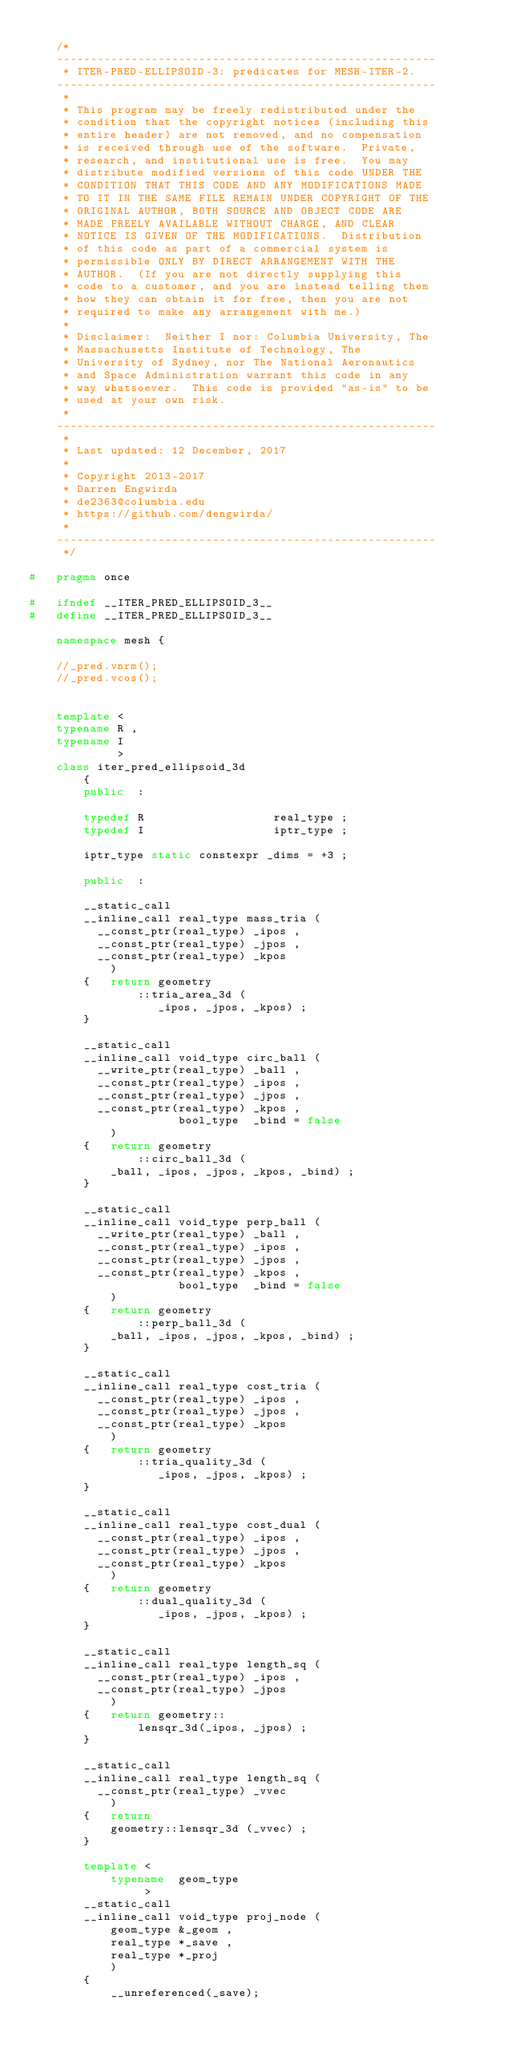Convert code to text. <code><loc_0><loc_0><loc_500><loc_500><_C++_>
    /*
    --------------------------------------------------------
     * ITER-PRED-ELLIPSOID-3: predicates for MESH-ITER-2.
    --------------------------------------------------------
     *
     * This program may be freely redistributed under the 
     * condition that the copyright notices (including this 
     * entire header) are not removed, and no compensation 
     * is received through use of the software.  Private, 
     * research, and institutional use is free.  You may 
     * distribute modified versions of this code UNDER THE 
     * CONDITION THAT THIS CODE AND ANY MODIFICATIONS MADE 
     * TO IT IN THE SAME FILE REMAIN UNDER COPYRIGHT OF THE 
     * ORIGINAL AUTHOR, BOTH SOURCE AND OBJECT CODE ARE 
     * MADE FREELY AVAILABLE WITHOUT CHARGE, AND CLEAR 
     * NOTICE IS GIVEN OF THE MODIFICATIONS.  Distribution 
     * of this code as part of a commercial system is 
     * permissible ONLY BY DIRECT ARRANGEMENT WITH THE 
     * AUTHOR.  (If you are not directly supplying this 
     * code to a customer, and you are instead telling them 
     * how they can obtain it for free, then you are not 
     * required to make any arrangement with me.) 
     *
     * Disclaimer:  Neither I nor: Columbia University, The
     * Massachusetts Institute of Technology, The 
     * University of Sydney, nor The National Aeronautics
     * and Space Administration warrant this code in any 
     * way whatsoever.  This code is provided "as-is" to be 
     * used at your own risk.
     *
    --------------------------------------------------------
     *
     * Last updated: 12 December, 2017
     *
     * Copyright 2013-2017
     * Darren Engwirda
     * de2363@columbia.edu
     * https://github.com/dengwirda/
     *
    --------------------------------------------------------
     */

#   pragma once

#   ifndef __ITER_PRED_ELLIPSOID_3__
#   define __ITER_PRED_ELLIPSOID_3__

    namespace mesh {

    //_pred.vnrm();
    //_pred.vcos();
    
    
    template <
    typename R ,
    typename I
             >
    class iter_pred_ellipsoid_3d
        {
        public  :
        
        typedef R                   real_type ;
        typedef I                   iptr_type ;
        
        iptr_type static constexpr _dims = +3 ; 
         
        public  :
        
        __static_call
        __inline_call real_type mass_tria (
          __const_ptr(real_type) _ipos ,
          __const_ptr(real_type) _jpos ,
          __const_ptr(real_type) _kpos
            )
        {   return geometry
                ::tria_area_3d (
                   _ipos, _jpos, _kpos) ;
        }
        
        __static_call
        __inline_call void_type circ_ball (
          __write_ptr(real_type) _ball ,
          __const_ptr(real_type) _ipos ,
          __const_ptr(real_type) _jpos ,
          __const_ptr(real_type) _kpos ,
                      bool_type  _bind = false
            )
        {   return geometry
                ::circ_ball_3d (
            _ball, _ipos, _jpos, _kpos, _bind) ;
        }
        
        __static_call
        __inline_call void_type perp_ball (
          __write_ptr(real_type) _ball ,
          __const_ptr(real_type) _ipos ,
          __const_ptr(real_type) _jpos ,
          __const_ptr(real_type) _kpos ,
                      bool_type  _bind = false
            )
        {   return geometry
                ::perp_ball_3d (
            _ball, _ipos, _jpos, _kpos, _bind) ;
        }
        
        __static_call
        __inline_call real_type cost_tria (
          __const_ptr(real_type) _ipos ,
          __const_ptr(real_type) _jpos ,
          __const_ptr(real_type) _kpos
            )
        {   return geometry
                ::tria_quality_3d (
                   _ipos, _jpos, _kpos) ;
        }
        
        __static_call
        __inline_call real_type cost_dual (
          __const_ptr(real_type) _ipos ,
          __const_ptr(real_type) _jpos ,
          __const_ptr(real_type) _kpos
            )
        {   return geometry
                ::dual_quality_3d (
                   _ipos, _jpos, _kpos) ;
        }
        
        __static_call
        __inline_call real_type length_sq (
          __const_ptr(real_type) _ipos ,
          __const_ptr(real_type) _jpos
            )
        {   return geometry::
                lensqr_3d(_ipos, _jpos) ;
        }
        
        __static_call
        __inline_call real_type length_sq (
          __const_ptr(real_type) _vvec
            )
        {   return 
            geometry::lensqr_3d (_vvec) ;
        }
      
        template <
            typename  geom_type
                 >
        __static_call
        __inline_call void_type proj_node (
            geom_type &_geom ,
            real_type *_save ,
            real_type *_proj
            )
        {
            __unreferenced(_save);
            </code> 